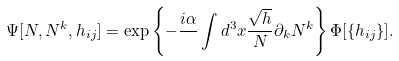<formula> <loc_0><loc_0><loc_500><loc_500>\Psi [ N , N ^ { k } , h _ { i j } ] = \exp \left \{ - \frac { i \alpha } { } \int d ^ { 3 } x \frac { \sqrt { h } } { N } \partial _ { k } N ^ { k } \right \} \Phi [ \{ h _ { i j } \} ] .</formula> 